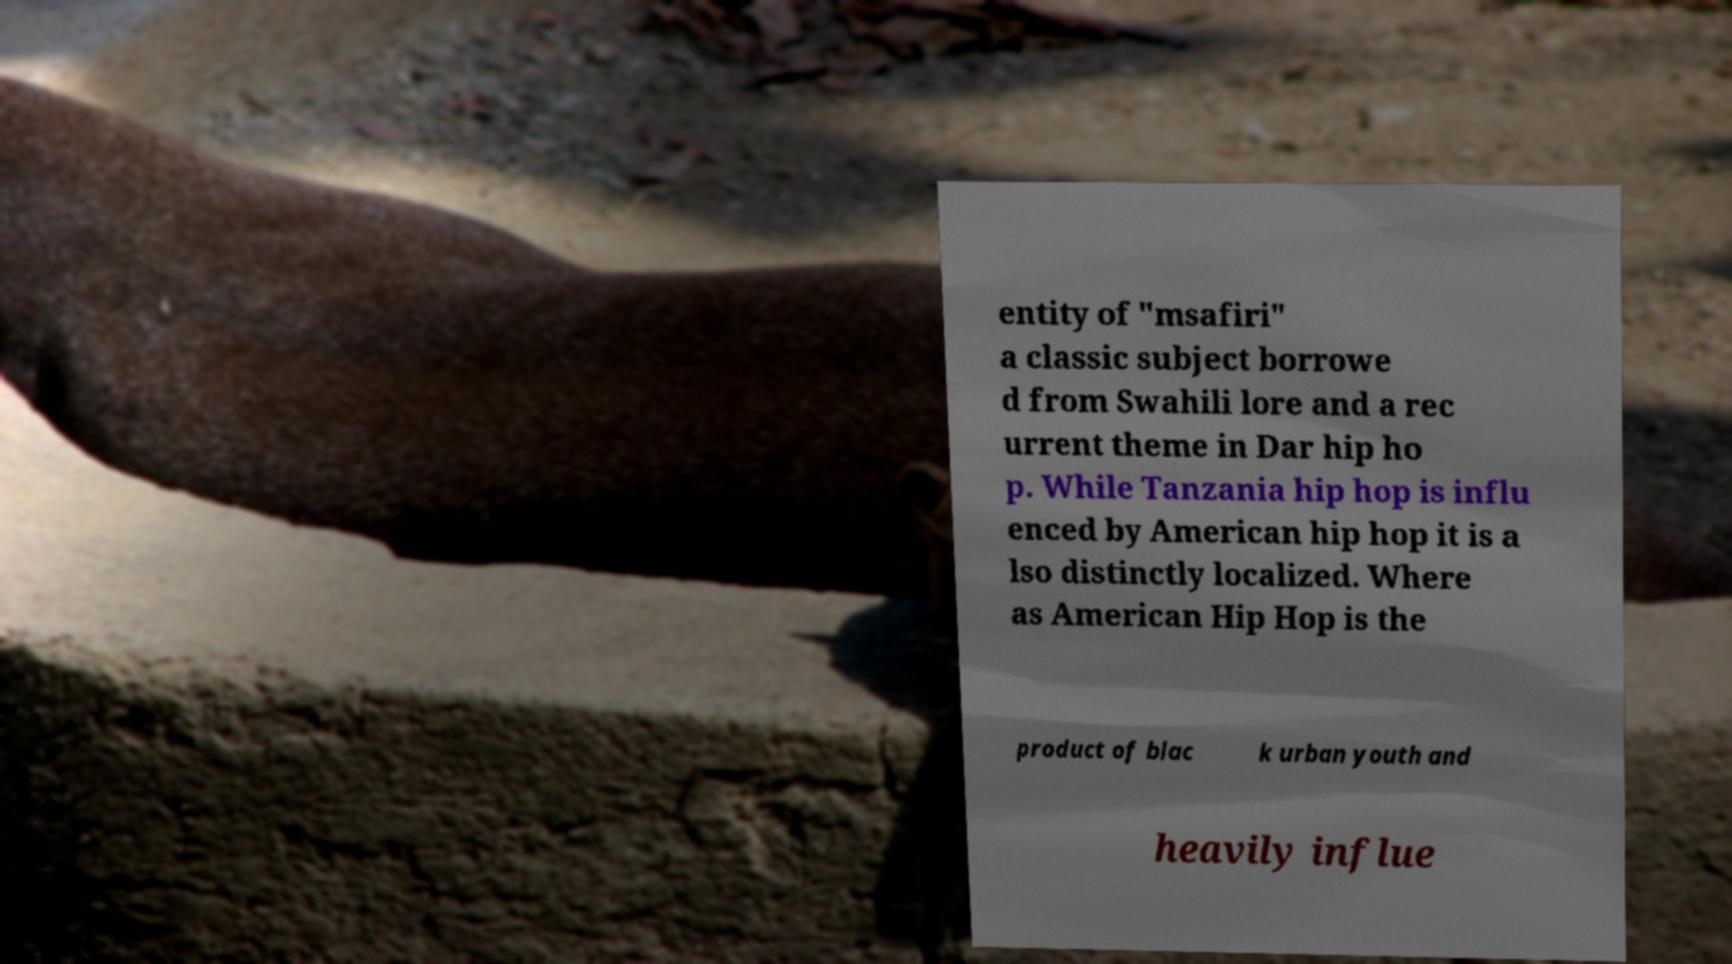Can you accurately transcribe the text from the provided image for me? entity of "msafiri" a classic subject borrowe d from Swahili lore and a rec urrent theme in Dar hip ho p. While Tanzania hip hop is influ enced by American hip hop it is a lso distinctly localized. Where as American Hip Hop is the product of blac k urban youth and heavily influe 